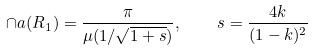Convert formula to latex. <formula><loc_0><loc_0><loc_500><loc_500>\cap a ( R _ { 1 } ) = \frac { \pi } { \mu ( 1 / \sqrt { 1 + s } ) } , \quad s = \frac { 4 k } { ( 1 - k ) ^ { 2 } }</formula> 